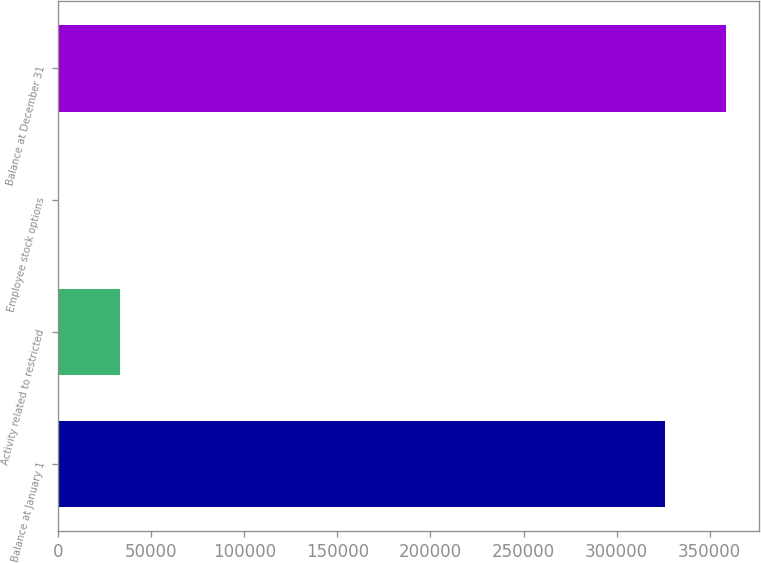Convert chart to OTSL. <chart><loc_0><loc_0><loc_500><loc_500><bar_chart><fcel>Balance at January 1<fcel>Activity related to restricted<fcel>Employee stock options<fcel>Balance at December 31<nl><fcel>326133<fcel>33097.3<fcel>416<fcel>358814<nl></chart> 